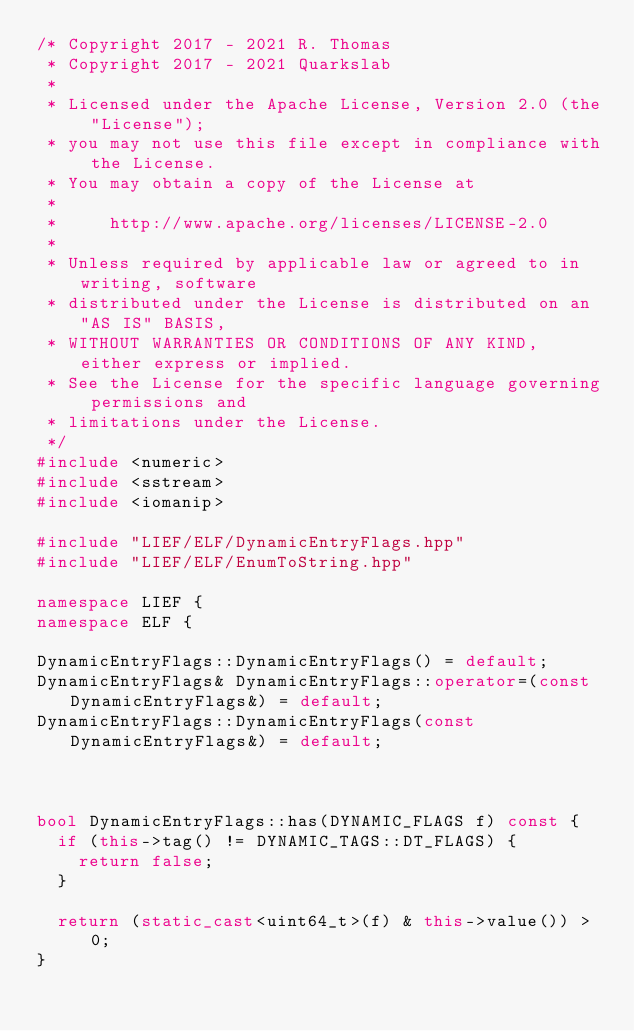<code> <loc_0><loc_0><loc_500><loc_500><_C++_>/* Copyright 2017 - 2021 R. Thomas
 * Copyright 2017 - 2021 Quarkslab
 *
 * Licensed under the Apache License, Version 2.0 (the "License");
 * you may not use this file except in compliance with the License.
 * You may obtain a copy of the License at
 *
 *     http://www.apache.org/licenses/LICENSE-2.0
 *
 * Unless required by applicable law or agreed to in writing, software
 * distributed under the License is distributed on an "AS IS" BASIS,
 * WITHOUT WARRANTIES OR CONDITIONS OF ANY KIND, either express or implied.
 * See the License for the specific language governing permissions and
 * limitations under the License.
 */
#include <numeric>
#include <sstream>
#include <iomanip>

#include "LIEF/ELF/DynamicEntryFlags.hpp"
#include "LIEF/ELF/EnumToString.hpp"

namespace LIEF {
namespace ELF {

DynamicEntryFlags::DynamicEntryFlags() = default;
DynamicEntryFlags& DynamicEntryFlags::operator=(const DynamicEntryFlags&) = default;
DynamicEntryFlags::DynamicEntryFlags(const DynamicEntryFlags&) = default;



bool DynamicEntryFlags::has(DYNAMIC_FLAGS f) const {
  if (this->tag() != DYNAMIC_TAGS::DT_FLAGS) {
    return false;
  }

  return (static_cast<uint64_t>(f) & this->value()) > 0;
}

</code> 